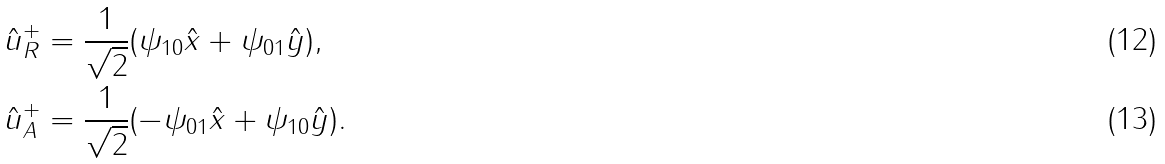Convert formula to latex. <formula><loc_0><loc_0><loc_500><loc_500>\hat { u } _ { R } ^ { + } & = \frac { 1 } { \sqrt { 2 } } ( \psi _ { 1 0 } \hat { x } + \psi _ { 0 1 } \hat { y } ) , \\ \hat { u } _ { A } ^ { + } & = \frac { 1 } { \sqrt { 2 } } ( - \psi _ { 0 1 } \hat { x } + \psi _ { 1 0 } \hat { y } ) .</formula> 